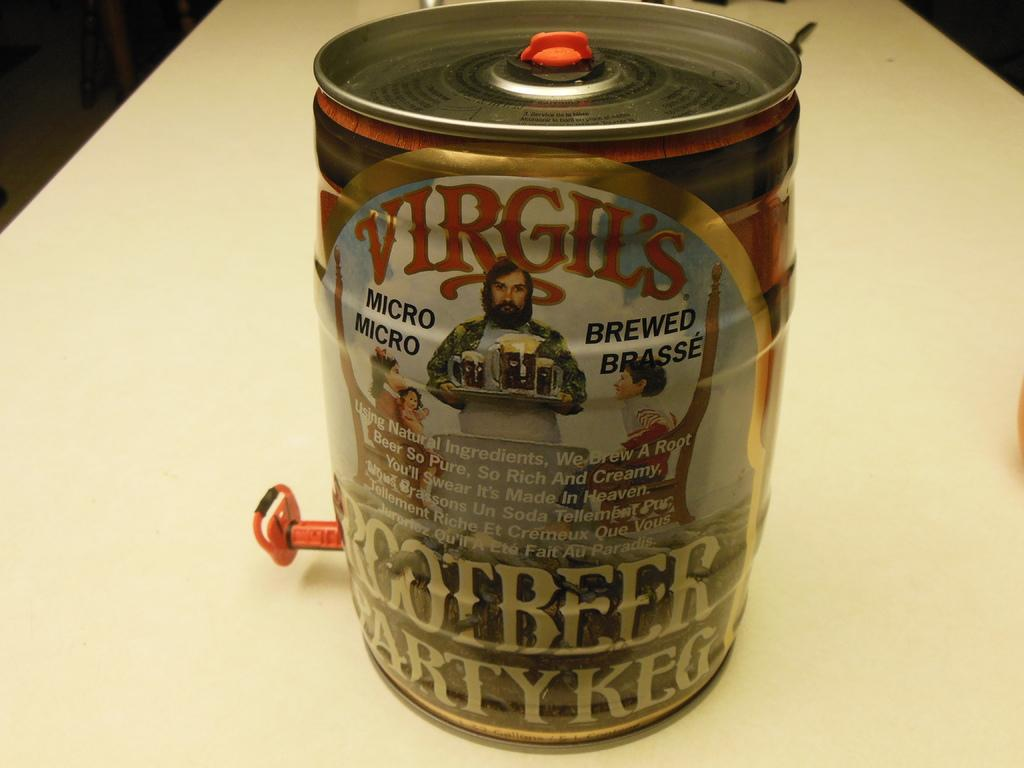<image>
Render a clear and concise summary of the photo. A party Keg of Virgil's micro brew will be served at the party. 